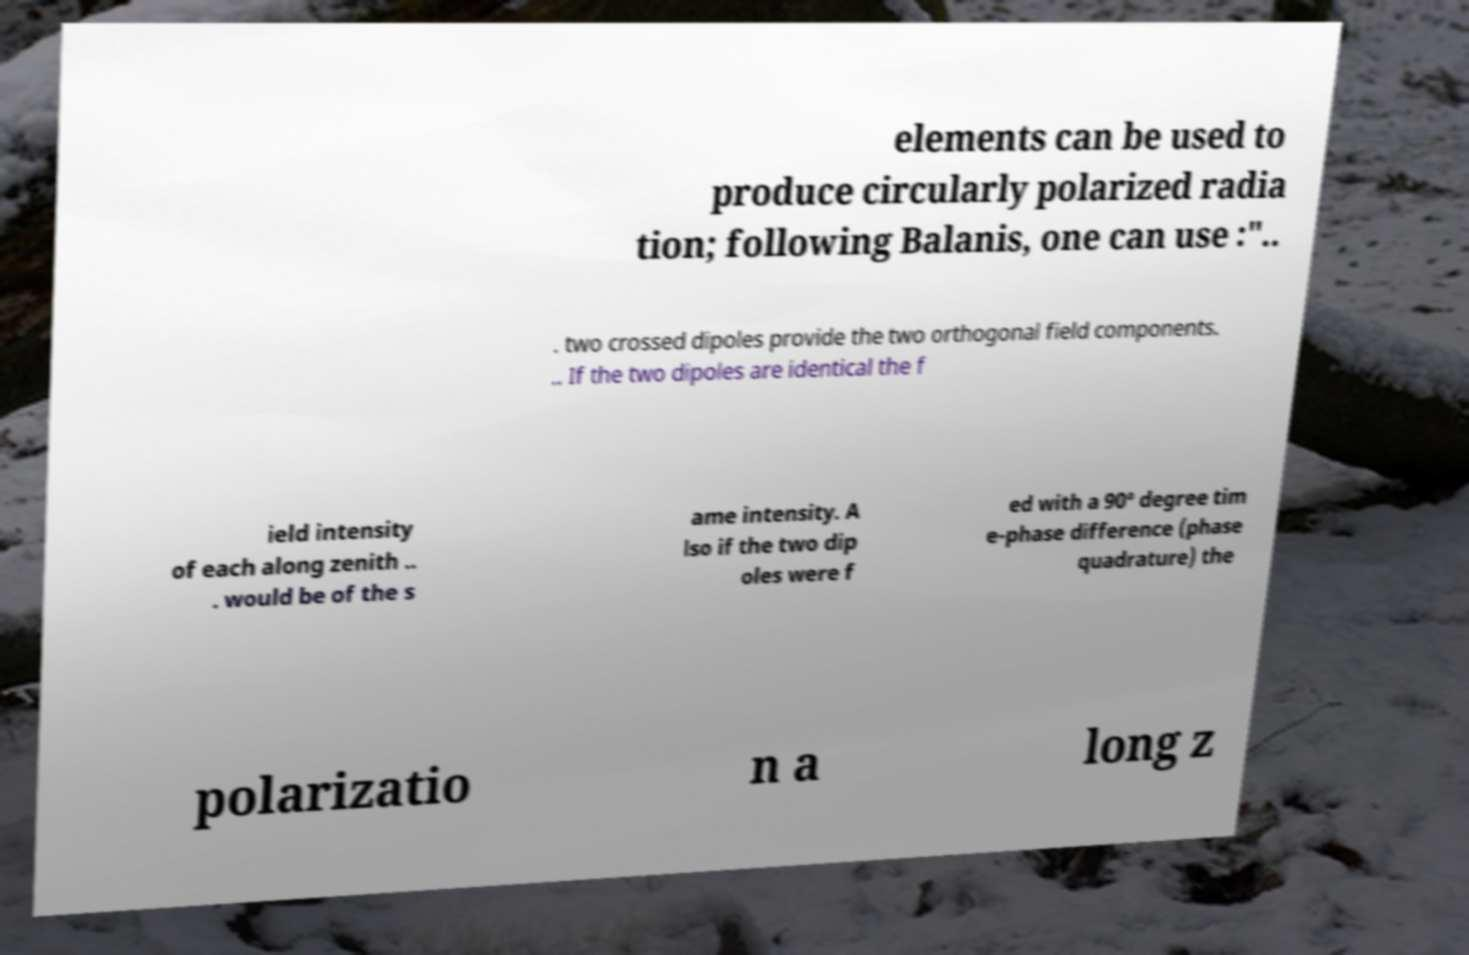For documentation purposes, I need the text within this image transcribed. Could you provide that? elements can be used to produce circularly polarized radia tion; following Balanis, one can use :".. . two crossed dipoles provide the two orthogonal field components. .. If the two dipoles are identical the f ield intensity of each along zenith .. . would be of the s ame intensity. A lso if the two dip oles were f ed with a 90° degree tim e-phase difference (phase quadrature) the polarizatio n a long z 